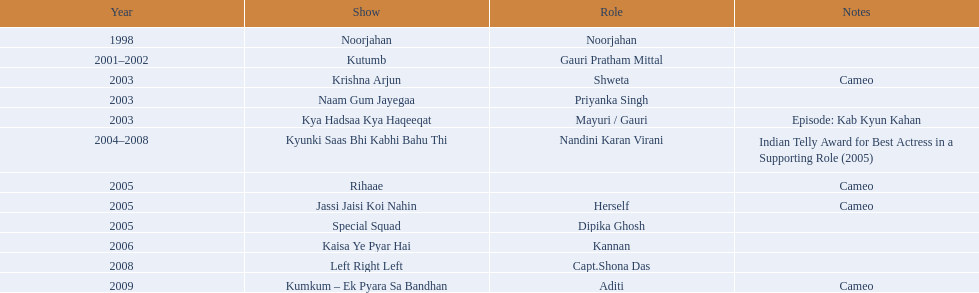What shows has gauri pradhan tejwani been in? Noorjahan, Kutumb, Krishna Arjun, Naam Gum Jayegaa, Kya Hadsaa Kya Haqeeqat, Kyunki Saas Bhi Kabhi Bahu Thi, Rihaae, Jassi Jaisi Koi Nahin, Special Squad, Kaisa Ye Pyar Hai, Left Right Left, Kumkum – Ek Pyara Sa Bandhan. Of these shows, which one lasted for more than a year? Kutumb, Kyunki Saas Bhi Kabhi Bahu Thi. Which of these lasted the longest? Kyunki Saas Bhi Kabhi Bahu Thi. 